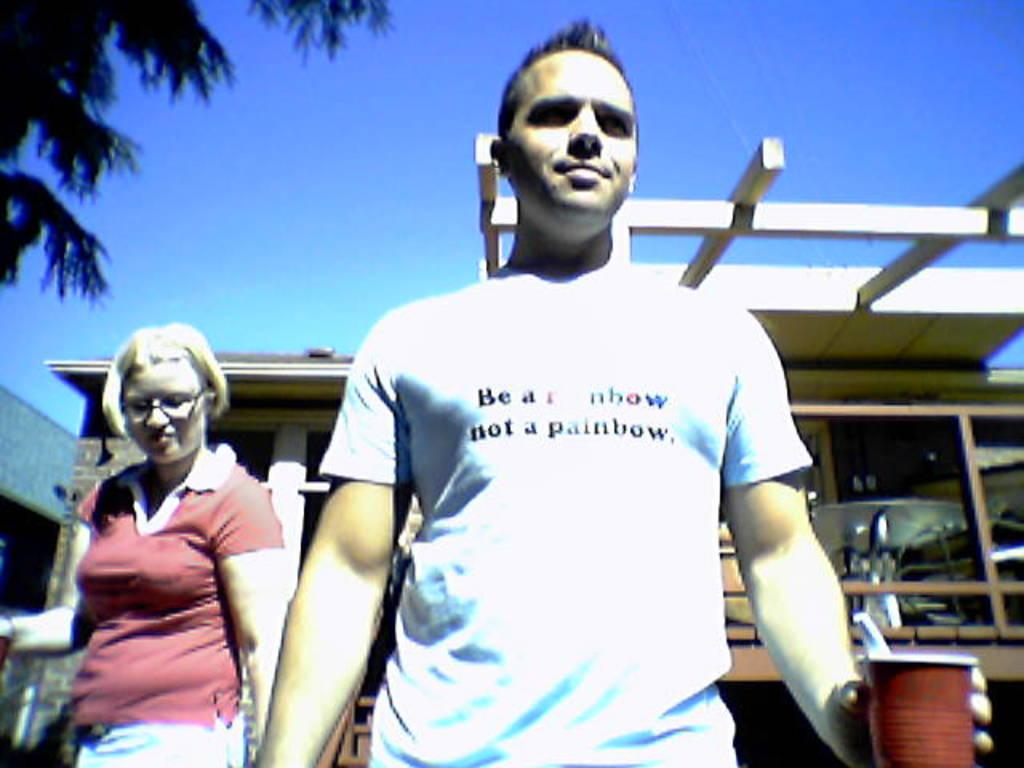What is the man holding in the image? The man is holding a cup in the image. Who is standing next to the man? There is a woman beside the man in the image. What can be seen in the distance behind the man and woman? There is a building in the background of the image. What color is the sky in the image? The sky is blue in the image. What type of fang can be seen in the image? There is no fang present in the image. How many yams are visible in the image? There are no yams present in the image. 